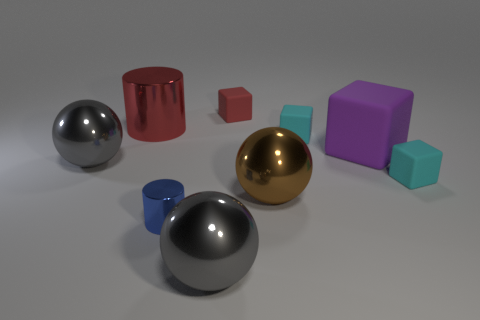There is a object that is the same color as the big shiny cylinder; what material is it?
Your answer should be very brief. Rubber. What number of other things are there of the same color as the large metal cylinder?
Give a very brief answer. 1. Is the small cylinder the same color as the big metallic cylinder?
Provide a short and direct response. No. How many large purple blocks are there?
Your response must be concise. 1. There is a small cyan cube behind the big gray metallic ball that is behind the tiny blue cylinder; what is it made of?
Provide a short and direct response. Rubber. There is a purple block that is the same size as the red cylinder; what material is it?
Ensure brevity in your answer.  Rubber. Is the size of the metallic ball that is to the right of the red matte thing the same as the blue cylinder?
Your answer should be compact. No. Is the shape of the gray metal thing in front of the brown shiny object the same as  the brown metal thing?
Provide a succinct answer. Yes. What number of objects are either tiny things or small cubes in front of the red matte thing?
Make the answer very short. 4. Are there fewer big matte blocks than cyan blocks?
Ensure brevity in your answer.  Yes. 